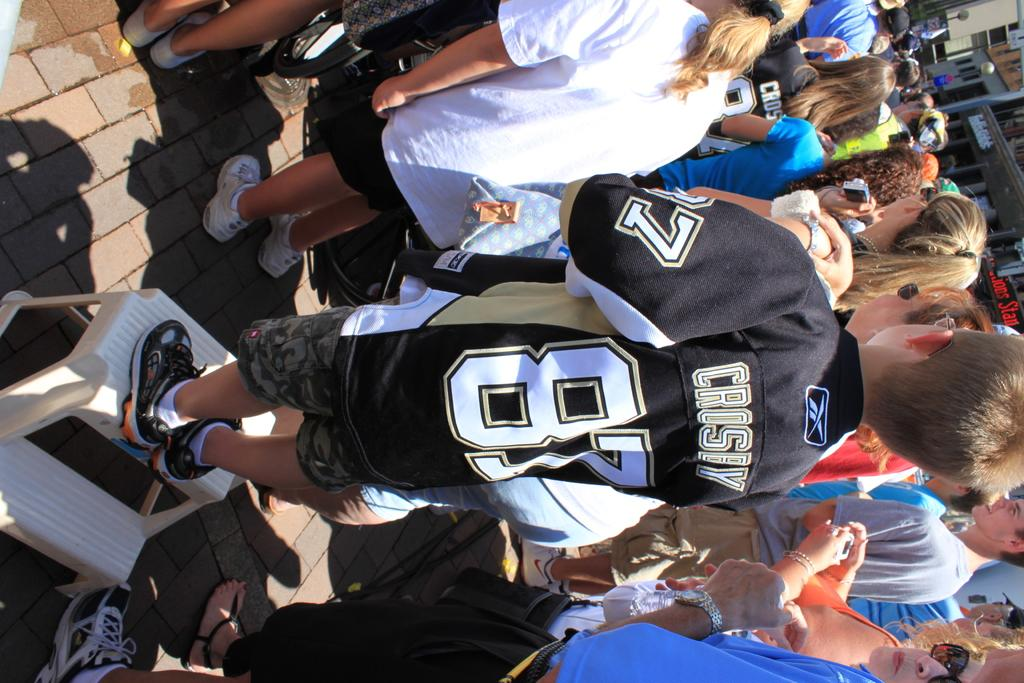<image>
Create a compact narrative representing the image presented. A boy wearing a jersey that says "Crosby 87" stands with other kids. 